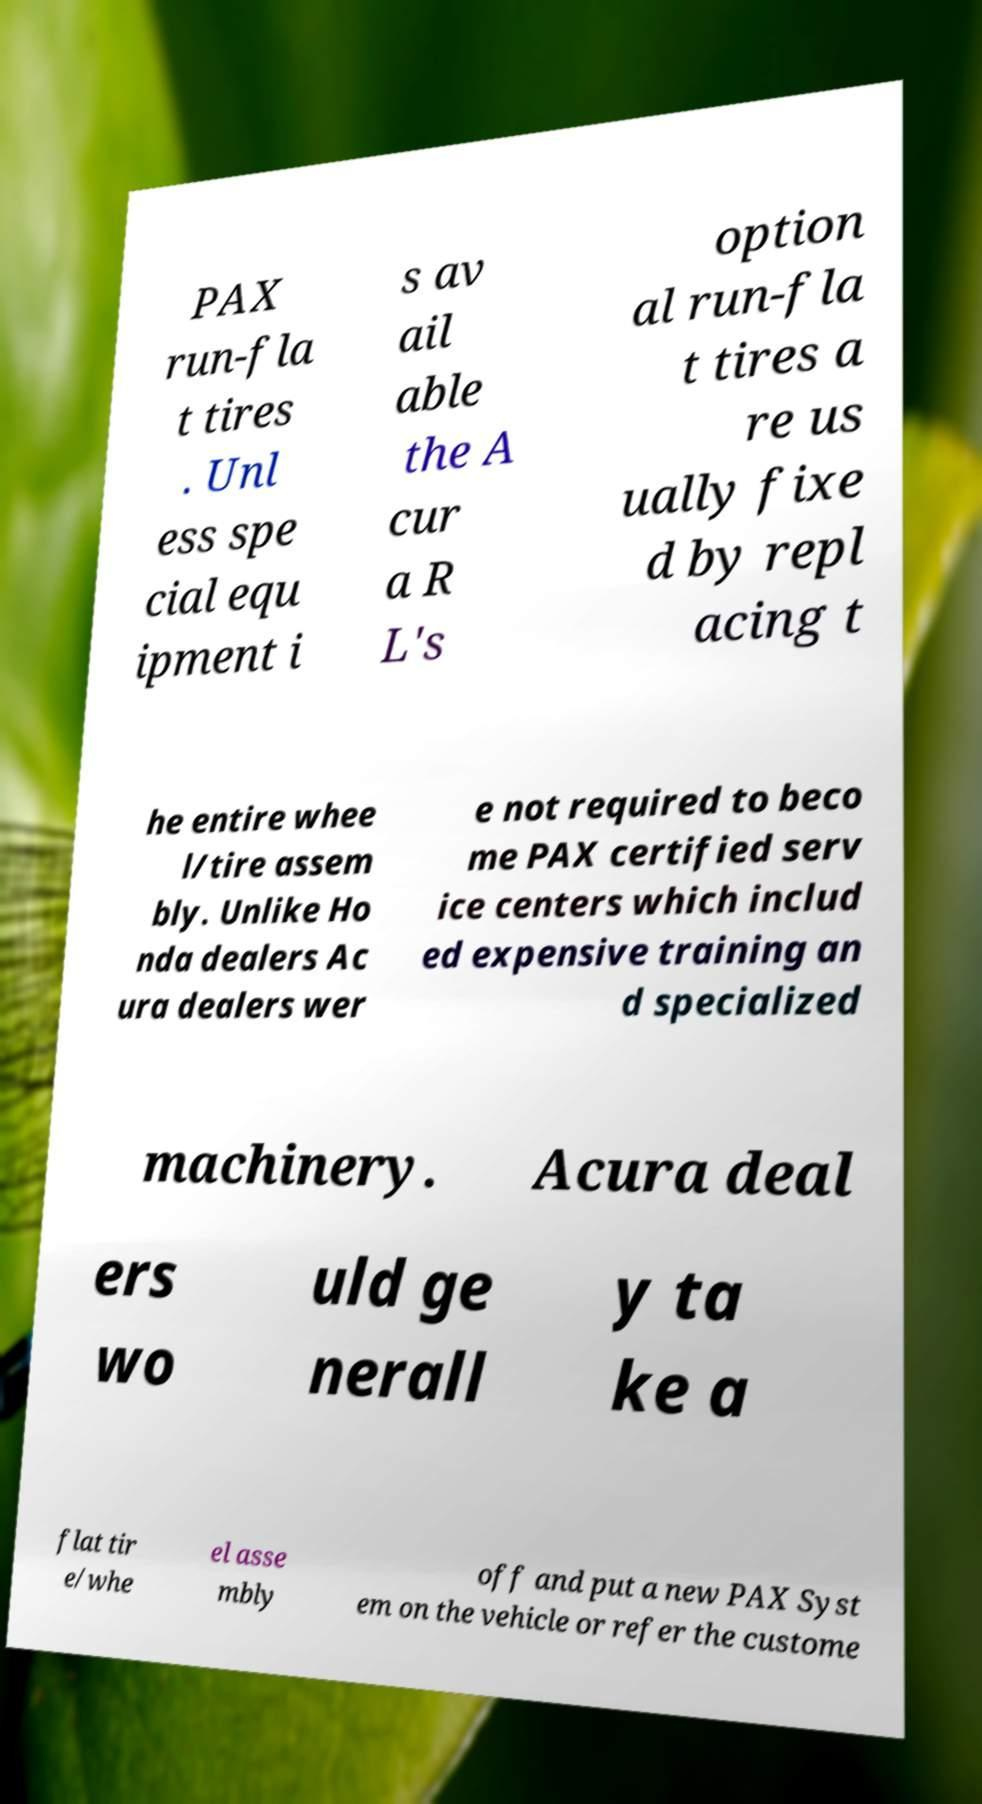Please read and relay the text visible in this image. What does it say? PAX run-fla t tires . Unl ess spe cial equ ipment i s av ail able the A cur a R L's option al run-fla t tires a re us ually fixe d by repl acing t he entire whee l/tire assem bly. Unlike Ho nda dealers Ac ura dealers wer e not required to beco me PAX certified serv ice centers which includ ed expensive training an d specialized machinery. Acura deal ers wo uld ge nerall y ta ke a flat tir e/whe el asse mbly off and put a new PAX Syst em on the vehicle or refer the custome 